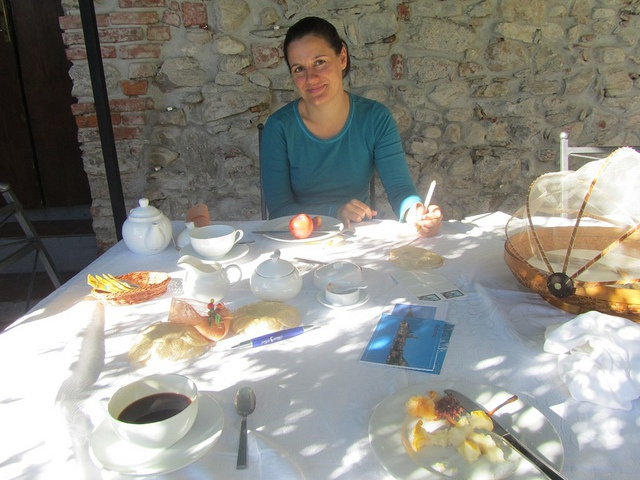Describe the objects in this image and their specific colors. I can see dining table in black, darkgray, white, gray, and tan tones, people in black, teal, and gray tones, bowl in black, white, darkgray, and gray tones, apple in black, tan, and khaki tones, and cup in black, lightgray, and darkgray tones in this image. 